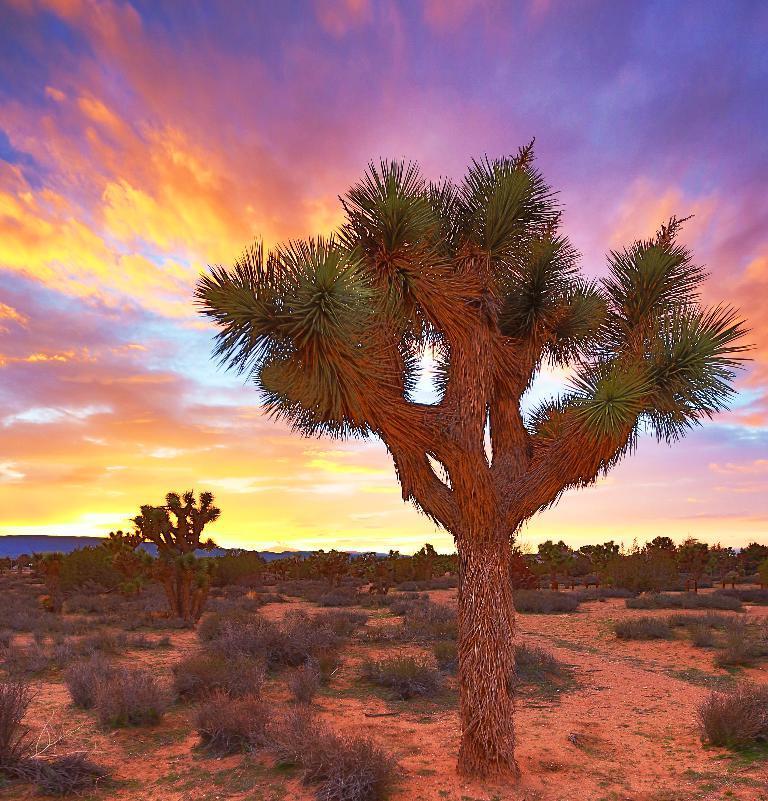Describe this image in one or two sentences. This picture seems to be a painting. In the foreground we can see the plants and a tree. In the background there is a sky, plants and trees. 